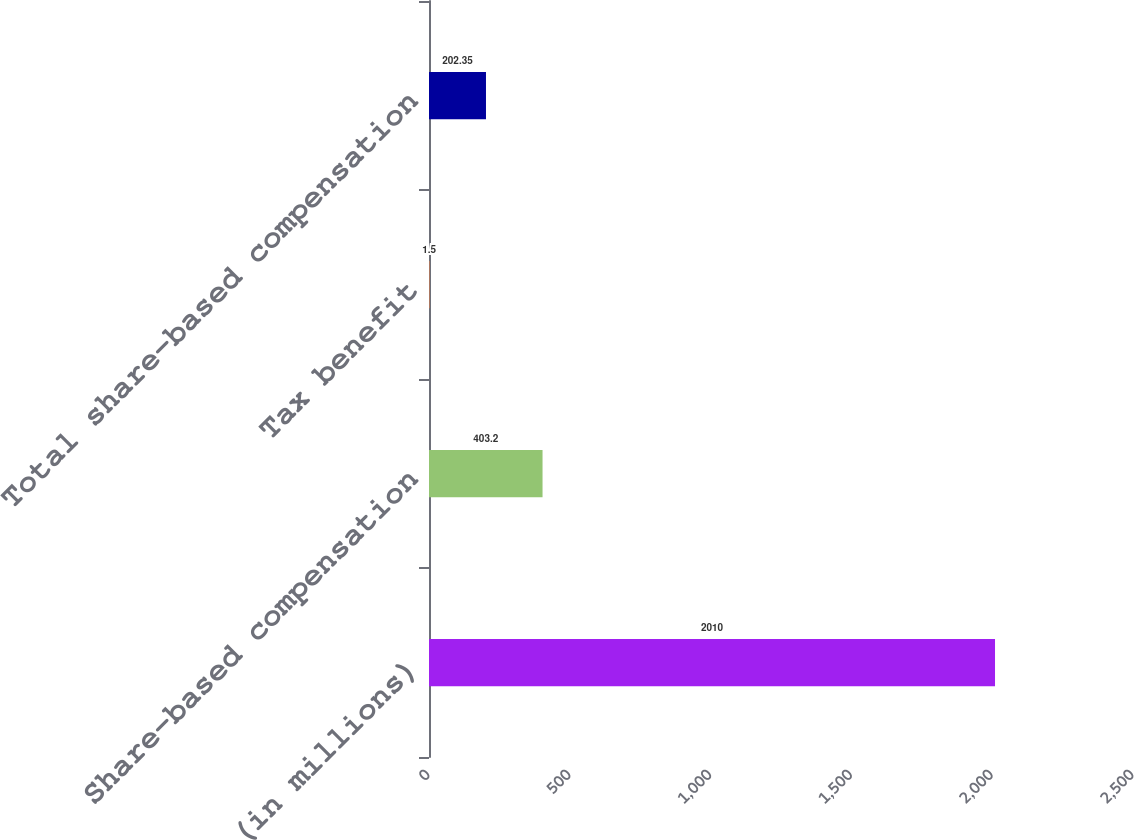<chart> <loc_0><loc_0><loc_500><loc_500><bar_chart><fcel>(in millions)<fcel>Share-based compensation<fcel>Tax benefit<fcel>Total share-based compensation<nl><fcel>2010<fcel>403.2<fcel>1.5<fcel>202.35<nl></chart> 